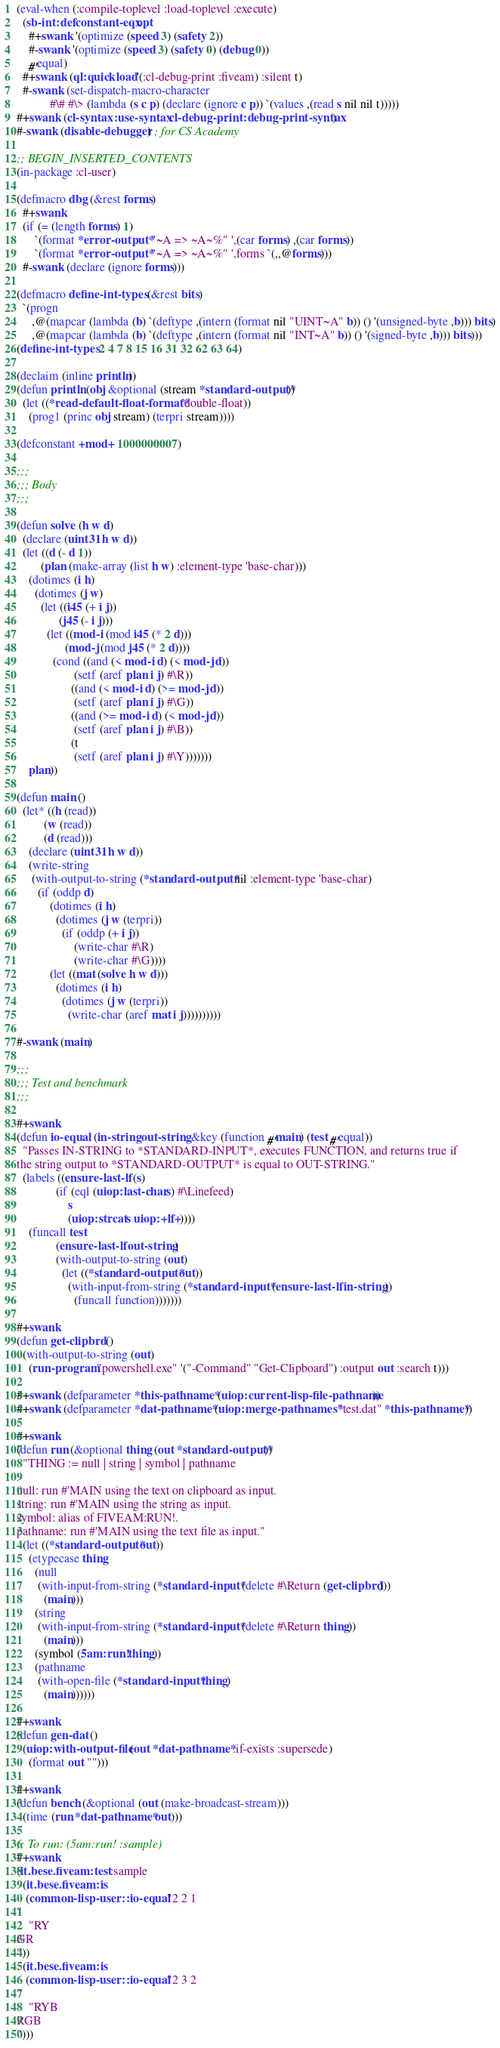Convert code to text. <code><loc_0><loc_0><loc_500><loc_500><_Lisp_>(eval-when (:compile-toplevel :load-toplevel :execute)
  (sb-int:defconstant-eqx opt
    #+swank '(optimize (speed 3) (safety 2))
    #-swank '(optimize (speed 3) (safety 0) (debug 0))
    #'equal)
  #+swank (ql:quickload '(:cl-debug-print :fiveam) :silent t)
  #-swank (set-dispatch-macro-character
           #\# #\> (lambda (s c p) (declare (ignore c p)) `(values ,(read s nil nil t)))))
#+swank (cl-syntax:use-syntax cl-debug-print:debug-print-syntax)
#-swank (disable-debugger) ; for CS Academy

;; BEGIN_INSERTED_CONTENTS
(in-package :cl-user)

(defmacro dbg (&rest forms)
  #+swank
  (if (= (length forms) 1)
      `(format *error-output* "~A => ~A~%" ',(car forms) ,(car forms))
      `(format *error-output* "~A => ~A~%" ',forms `(,,@forms)))
  #-swank (declare (ignore forms)))

(defmacro define-int-types (&rest bits)
  `(progn
     ,@(mapcar (lambda (b) `(deftype ,(intern (format nil "UINT~A" b)) () '(unsigned-byte ,b))) bits)
     ,@(mapcar (lambda (b) `(deftype ,(intern (format nil "INT~A" b)) () '(signed-byte ,b))) bits)))
(define-int-types 2 4 7 8 15 16 31 32 62 63 64)

(declaim (inline println))
(defun println (obj &optional (stream *standard-output*))
  (let ((*read-default-float-format* 'double-float))
    (prog1 (princ obj stream) (terpri stream))))

(defconstant +mod+ 1000000007)

;;;
;;; Body
;;;

(defun solve (h w d)
  (declare (uint31 h w d))
  (let ((d (- d 1))
        (plan (make-array (list h w) :element-type 'base-char)))
    (dotimes (i h)
      (dotimes (j w)
        (let ((i45 (+ i j))
              (j45 (- i j)))
          (let ((mod-i (mod i45 (* 2 d)))
                (mod-j (mod j45 (* 2 d))))
            (cond ((and (< mod-i d) (< mod-j d))
                   (setf (aref plan i j) #\R))
                  ((and (< mod-i d) (>= mod-j d))
                   (setf (aref plan i j) #\G))
                  ((and (>= mod-i d) (< mod-j d))
                   (setf (aref plan i j) #\B))
                  (t
                   (setf (aref plan i j) #\Y)))))))
    plan))

(defun main ()
  (let* ((h (read))
         (w (read))
         (d (read)))
    (declare (uint31 h w d))
    (write-string
     (with-output-to-string (*standard-output* nil :element-type 'base-char)
       (if (oddp d)
           (dotimes (i h)
             (dotimes (j w (terpri))
               (if (oddp (+ i j))
                   (write-char #\R)
                   (write-char #\G))))
           (let ((mat (solve h w d)))
             (dotimes (i h)
               (dotimes (j w (terpri))
                 (write-char (aref mat i j))))))))))

#-swank (main)

;;;
;;; Test and benchmark
;;;

#+swank
(defun io-equal (in-string out-string &key (function #'main) (test #'equal))
  "Passes IN-STRING to *STANDARD-INPUT*, executes FUNCTION, and returns true if
the string output to *STANDARD-OUTPUT* is equal to OUT-STRING."
  (labels ((ensure-last-lf (s)
             (if (eql (uiop:last-char s) #\Linefeed)
                 s
                 (uiop:strcat s uiop:+lf+))))
    (funcall test
             (ensure-last-lf out-string)
             (with-output-to-string (out)
               (let ((*standard-output* out))
                 (with-input-from-string (*standard-input* (ensure-last-lf in-string))
                   (funcall function)))))))

#+swank
(defun get-clipbrd ()
  (with-output-to-string (out)
    (run-program "powershell.exe" '("-Command" "Get-Clipboard") :output out :search t)))

#+swank (defparameter *this-pathname* (uiop:current-lisp-file-pathname))
#+swank (defparameter *dat-pathname* (uiop:merge-pathnames* "test.dat" *this-pathname*))

#+swank
(defun run (&optional thing (out *standard-output*))
  "THING := null | string | symbol | pathname

null: run #'MAIN using the text on clipboard as input.
string: run #'MAIN using the string as input.
symbol: alias of FIVEAM:RUN!.
pathname: run #'MAIN using the text file as input."
  (let ((*standard-output* out))
    (etypecase thing
      (null
       (with-input-from-string (*standard-input* (delete #\Return (get-clipbrd)))
         (main)))
      (string
       (with-input-from-string (*standard-input* (delete #\Return thing))
         (main)))
      (symbol (5am:run! thing))
      (pathname
       (with-open-file (*standard-input* thing)
         (main))))))

#+swank
(defun gen-dat ()
  (uiop:with-output-file (out *dat-pathname* :if-exists :supersede)
    (format out "")))

#+swank
(defun bench (&optional (out (make-broadcast-stream)))
  (time (run *dat-pathname* out)))

;; To run: (5am:run! :sample)
#+swank
(it.bese.fiveam:test :sample
  (it.bese.fiveam:is
   (common-lisp-user::io-equal "2 2 1
"
    "RY
GR
"))
  (it.bese.fiveam:is
   (common-lisp-user::io-equal "2 3 2
"
    "RYB
RGB
")))
</code> 